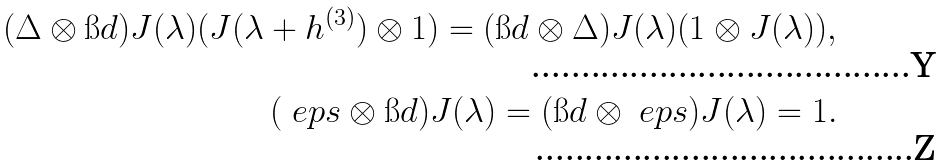Convert formula to latex. <formula><loc_0><loc_0><loc_500><loc_500>( \Delta \otimes \i d ) J ( \lambda ) ( J ( \lambda + h ^ { ( 3 ) } ) \otimes 1 ) = ( \i d \otimes \Delta ) J ( \lambda ) ( 1 \otimes J ( \lambda ) ) , \\ ( \ e p s \otimes \i d ) J ( \lambda ) = ( \i d \otimes \ e p s ) J ( \lambda ) = 1 .</formula> 